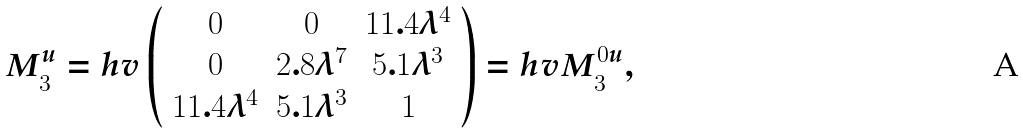Convert formula to latex. <formula><loc_0><loc_0><loc_500><loc_500>M ^ { u } _ { 3 } = h v \left ( \begin{array} { c c c } 0 & 0 & 1 1 . 4 \lambda ^ { 4 } \\ 0 & 2 . 8 \lambda ^ { 7 } & 5 . 1 \lambda ^ { 3 } \\ 1 1 . 4 \lambda ^ { 4 } & 5 . 1 \lambda ^ { 3 } & 1 \\ \end{array} \right ) = h v M ^ { 0 u } _ { 3 } ,</formula> 